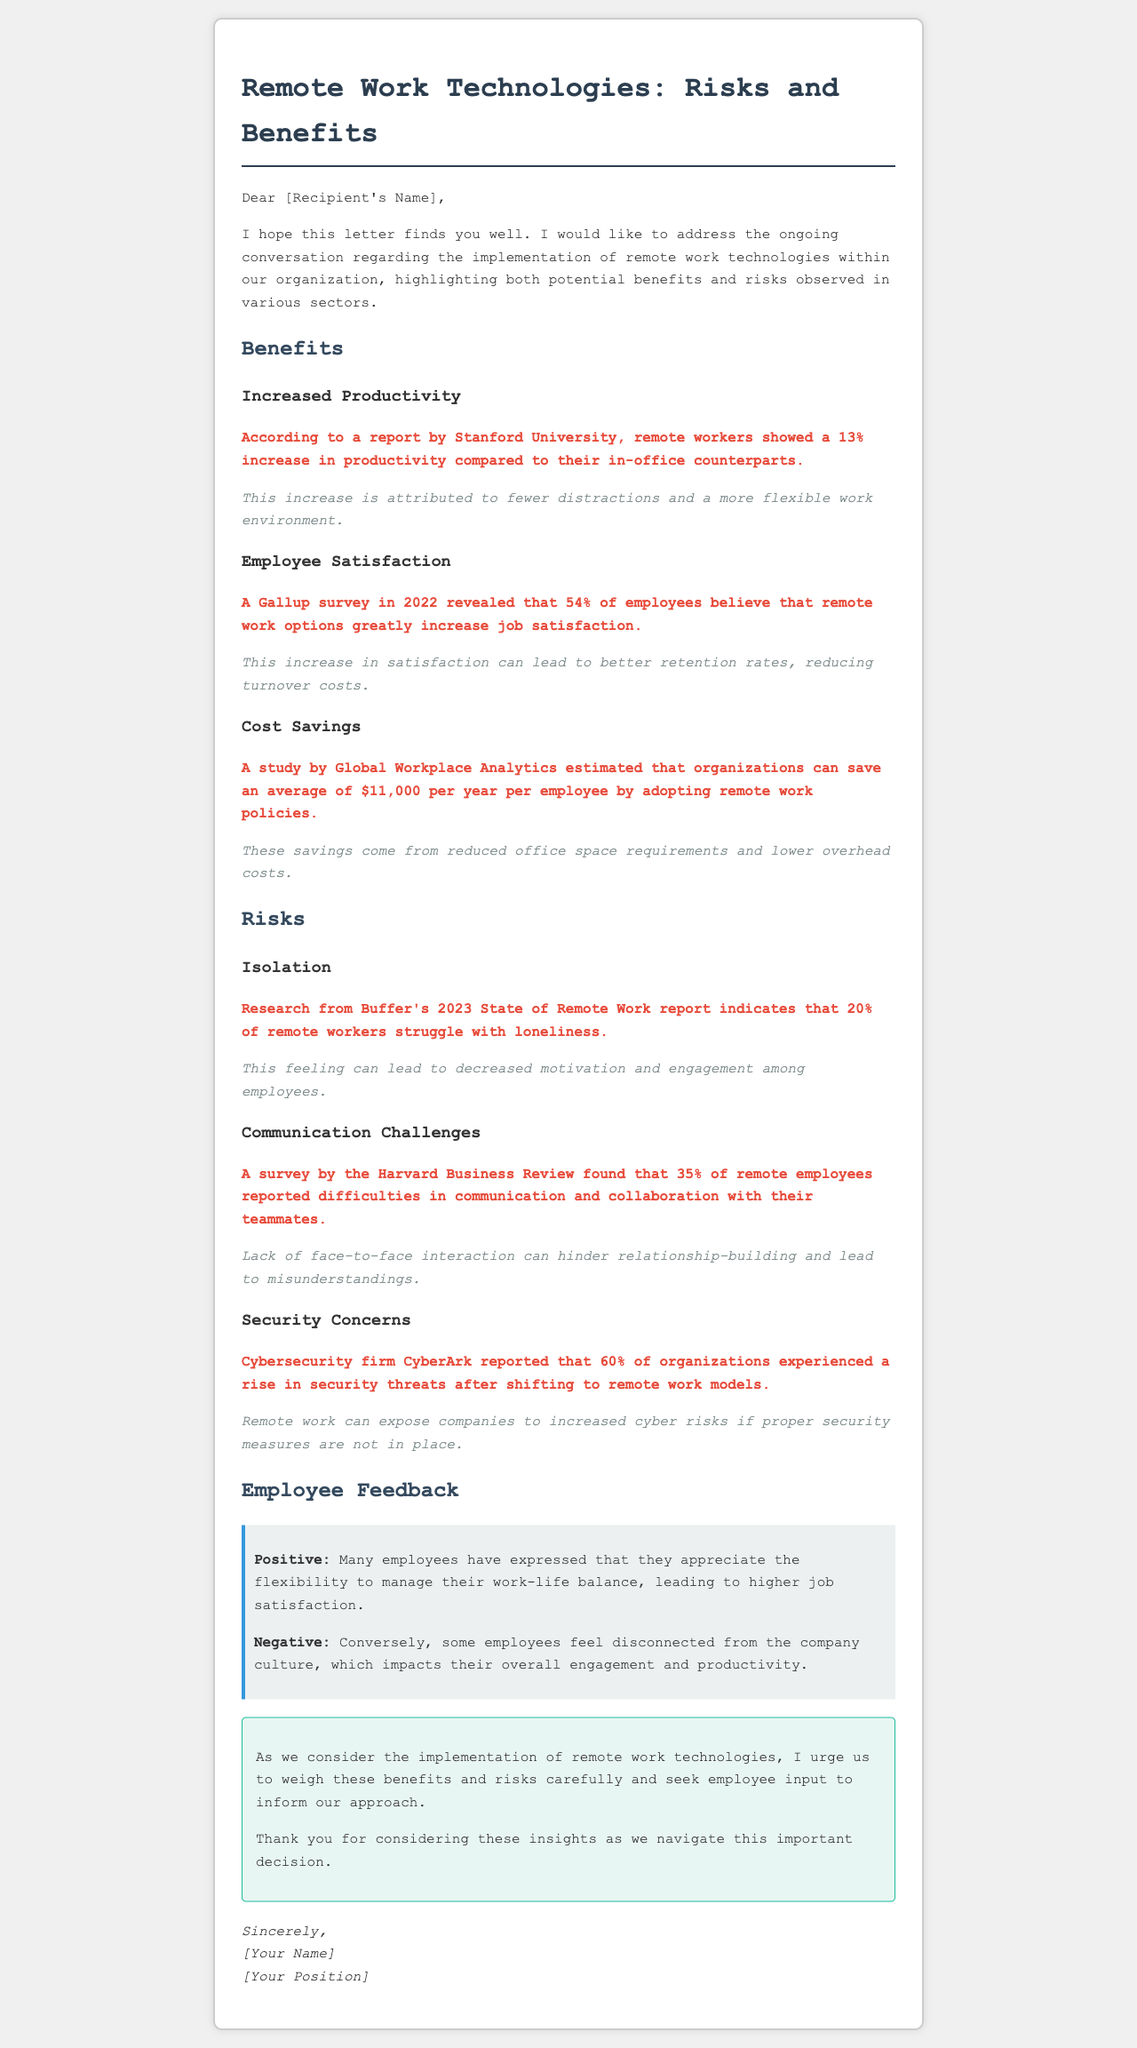What is the productivity increase percentage reported by Stanford University? The document states that remote workers showed a 13% increase in productivity compared to their in-office counterparts.
Answer: 13% What percentage of employees believe remote work increases job satisfaction? According to the Gallup survey in 2022, 54% of employees believe that remote work options greatly increase job satisfaction.
Answer: 54% What is the average savings per employee estimated by Global Workplace Analytics? A study estimated that organizations can save an average of $11,000 per year per employee by adopting remote work policies.
Answer: $11,000 What percentage of remote workers struggle with loneliness according to Buffer's 2023 report? Research from Buffer's 2023 State of Remote Work report indicates that 20% of remote workers struggle with loneliness.
Answer: 20% What percentage of remote employees reported difficulties in communication and collaboration? The Harvard Business Review survey found that 35% of remote employees reported difficulties in communication and collaboration with their teammates.
Answer: 35% What cybersecurity issue is highlighted in the document? The document mentions that 60% of organizations experienced a rise in security threats after shifting to remote work models.
Answer: Rise in security threats What are two aspects of employee feedback mentioned in the letter? The letter includes positive feedback about flexibility and negative feedback about disconnection from company culture.
Answer: Flexibility and disconnection What does the conclusion urge regarding employee input? The conclusion urges to seek employee input to inform the approach regarding remote work technologies.
Answer: Seek employee input 